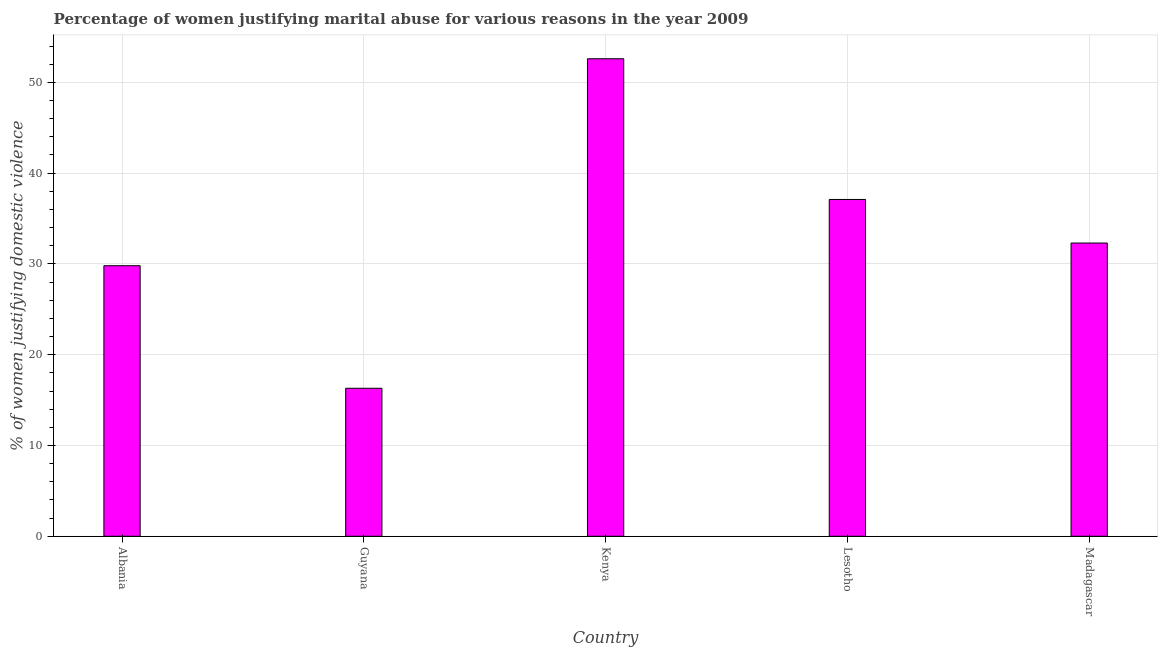Does the graph contain grids?
Make the answer very short. Yes. What is the title of the graph?
Your response must be concise. Percentage of women justifying marital abuse for various reasons in the year 2009. What is the label or title of the X-axis?
Provide a succinct answer. Country. What is the label or title of the Y-axis?
Keep it short and to the point. % of women justifying domestic violence. What is the percentage of women justifying marital abuse in Guyana?
Provide a succinct answer. 16.3. Across all countries, what is the maximum percentage of women justifying marital abuse?
Offer a very short reply. 52.6. In which country was the percentage of women justifying marital abuse maximum?
Your answer should be very brief. Kenya. In which country was the percentage of women justifying marital abuse minimum?
Keep it short and to the point. Guyana. What is the sum of the percentage of women justifying marital abuse?
Keep it short and to the point. 168.1. What is the difference between the percentage of women justifying marital abuse in Kenya and Lesotho?
Ensure brevity in your answer.  15.5. What is the average percentage of women justifying marital abuse per country?
Provide a short and direct response. 33.62. What is the median percentage of women justifying marital abuse?
Keep it short and to the point. 32.3. In how many countries, is the percentage of women justifying marital abuse greater than 30 %?
Keep it short and to the point. 3. What is the ratio of the percentage of women justifying marital abuse in Albania to that in Lesotho?
Make the answer very short. 0.8. Is the sum of the percentage of women justifying marital abuse in Kenya and Lesotho greater than the maximum percentage of women justifying marital abuse across all countries?
Your response must be concise. Yes. What is the difference between the highest and the lowest percentage of women justifying marital abuse?
Offer a terse response. 36.3. In how many countries, is the percentage of women justifying marital abuse greater than the average percentage of women justifying marital abuse taken over all countries?
Your answer should be very brief. 2. How many bars are there?
Offer a terse response. 5. Are all the bars in the graph horizontal?
Your response must be concise. No. How many countries are there in the graph?
Make the answer very short. 5. Are the values on the major ticks of Y-axis written in scientific E-notation?
Your answer should be compact. No. What is the % of women justifying domestic violence of Albania?
Give a very brief answer. 29.8. What is the % of women justifying domestic violence of Kenya?
Provide a succinct answer. 52.6. What is the % of women justifying domestic violence of Lesotho?
Your answer should be compact. 37.1. What is the % of women justifying domestic violence of Madagascar?
Ensure brevity in your answer.  32.3. What is the difference between the % of women justifying domestic violence in Albania and Guyana?
Make the answer very short. 13.5. What is the difference between the % of women justifying domestic violence in Albania and Kenya?
Your answer should be very brief. -22.8. What is the difference between the % of women justifying domestic violence in Albania and Lesotho?
Offer a very short reply. -7.3. What is the difference between the % of women justifying domestic violence in Albania and Madagascar?
Offer a terse response. -2.5. What is the difference between the % of women justifying domestic violence in Guyana and Kenya?
Your response must be concise. -36.3. What is the difference between the % of women justifying domestic violence in Guyana and Lesotho?
Your answer should be compact. -20.8. What is the difference between the % of women justifying domestic violence in Guyana and Madagascar?
Keep it short and to the point. -16. What is the difference between the % of women justifying domestic violence in Kenya and Madagascar?
Your response must be concise. 20.3. What is the ratio of the % of women justifying domestic violence in Albania to that in Guyana?
Provide a short and direct response. 1.83. What is the ratio of the % of women justifying domestic violence in Albania to that in Kenya?
Provide a short and direct response. 0.57. What is the ratio of the % of women justifying domestic violence in Albania to that in Lesotho?
Give a very brief answer. 0.8. What is the ratio of the % of women justifying domestic violence in Albania to that in Madagascar?
Keep it short and to the point. 0.92. What is the ratio of the % of women justifying domestic violence in Guyana to that in Kenya?
Make the answer very short. 0.31. What is the ratio of the % of women justifying domestic violence in Guyana to that in Lesotho?
Ensure brevity in your answer.  0.44. What is the ratio of the % of women justifying domestic violence in Guyana to that in Madagascar?
Your answer should be very brief. 0.51. What is the ratio of the % of women justifying domestic violence in Kenya to that in Lesotho?
Provide a succinct answer. 1.42. What is the ratio of the % of women justifying domestic violence in Kenya to that in Madagascar?
Give a very brief answer. 1.63. What is the ratio of the % of women justifying domestic violence in Lesotho to that in Madagascar?
Your response must be concise. 1.15. 